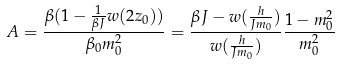<formula> <loc_0><loc_0><loc_500><loc_500>A = \frac { \beta ( 1 - \frac { 1 } { \beta J } w ( 2 z _ { 0 } ) ) } { \beta _ { 0 } m ^ { 2 } _ { 0 } } = { \frac { \beta J - w ( \frac { h } { J m _ { 0 } } ) } { w ( \frac { h } { J m _ { 0 } } ) } } { \frac { 1 - m ^ { 2 } _ { 0 } } { m ^ { 2 } _ { 0 } } }</formula> 